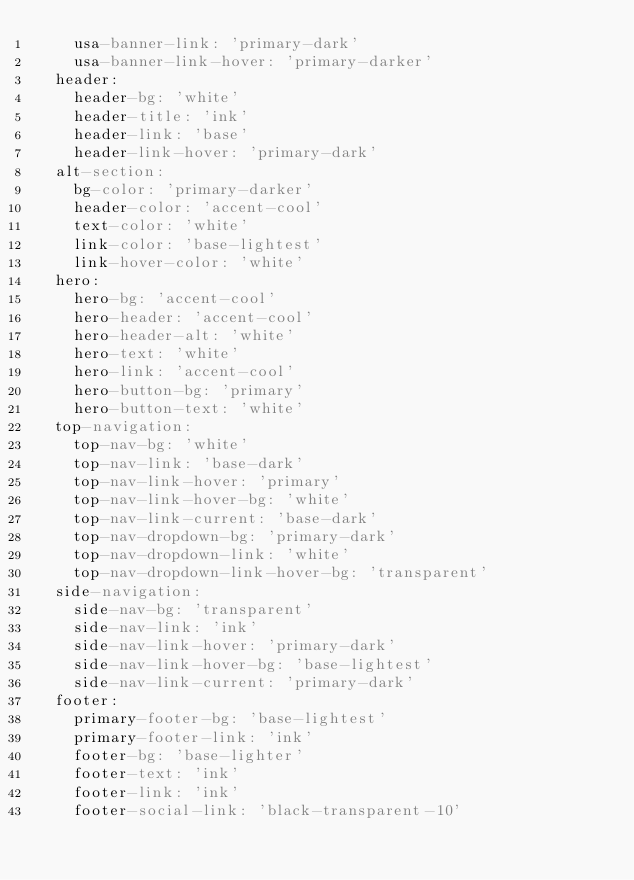Convert code to text. <code><loc_0><loc_0><loc_500><loc_500><_YAML_>    usa-banner-link: 'primary-dark'
    usa-banner-link-hover: 'primary-darker'
  header:
    header-bg: 'white'
    header-title: 'ink'
    header-link: 'base'
    header-link-hover: 'primary-dark'
  alt-section:
    bg-color: 'primary-darker'
    header-color: 'accent-cool'
    text-color: 'white'
    link-color: 'base-lightest'
    link-hover-color: 'white'
  hero:
    hero-bg: 'accent-cool'
    hero-header: 'accent-cool'
    hero-header-alt: 'white'
    hero-text: 'white'
    hero-link: 'accent-cool'
    hero-button-bg: 'primary'
    hero-button-text: 'white'
  top-navigation:
    top-nav-bg: 'white'
    top-nav-link: 'base-dark'
    top-nav-link-hover: 'primary'
    top-nav-link-hover-bg: 'white'
    top-nav-link-current: 'base-dark'
    top-nav-dropdown-bg: 'primary-dark'
    top-nav-dropdown-link: 'white'
    top-nav-dropdown-link-hover-bg: 'transparent'
  side-navigation:
    side-nav-bg: 'transparent'
    side-nav-link: 'ink'
    side-nav-link-hover: 'primary-dark'
    side-nav-link-hover-bg: 'base-lightest'
    side-nav-link-current: 'primary-dark'
  footer:
    primary-footer-bg: 'base-lightest'
    primary-footer-link: 'ink'
    footer-bg: 'base-lighter'
    footer-text: 'ink'
    footer-link: 'ink'
    footer-social-link: 'black-transparent-10'</code> 